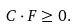<formula> <loc_0><loc_0><loc_500><loc_500>\label l { C F } C \cdot F \geq 0 .</formula> 